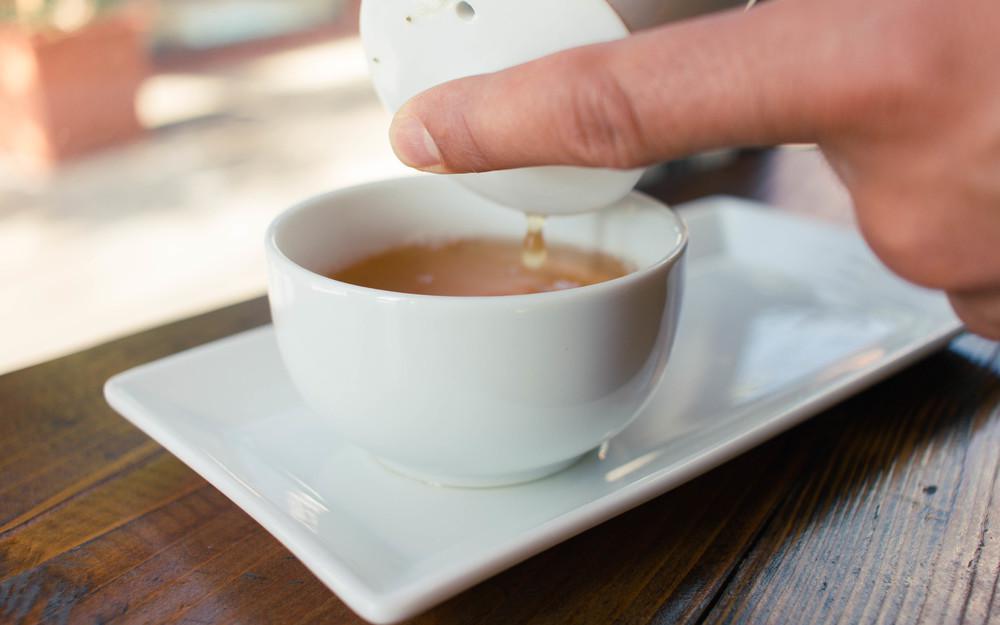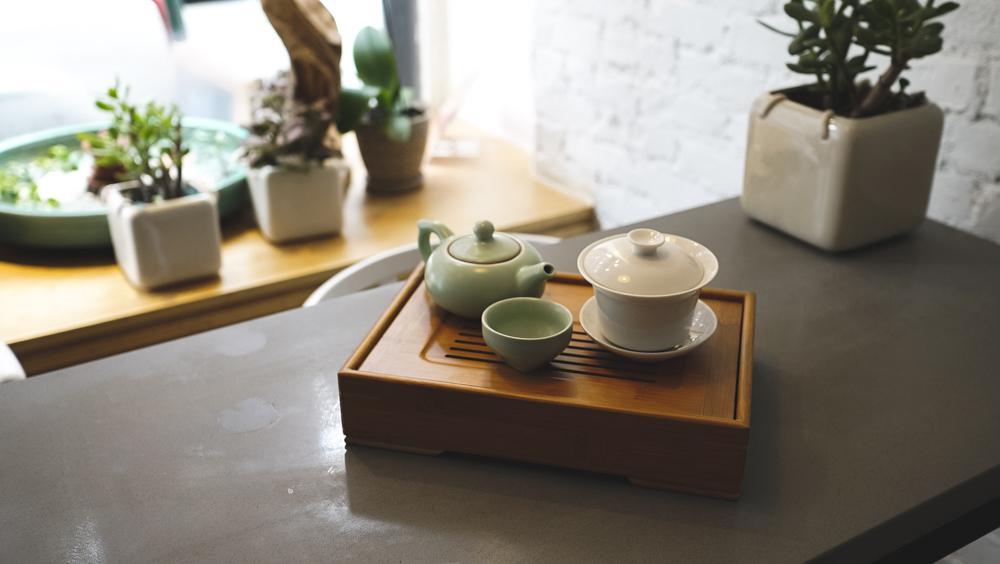The first image is the image on the left, the second image is the image on the right. Assess this claim about the two images: "In at least one image there is a single white cup of coffee on a plate that is all sitting on brown wooden table.". Correct or not? Answer yes or no. Yes. 